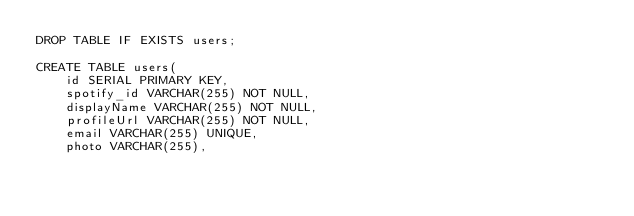<code> <loc_0><loc_0><loc_500><loc_500><_SQL_>DROP TABLE IF EXISTS users;

CREATE TABLE users(
    id SERIAL PRIMARY KEY,
    spotify_id VARCHAR(255) NOT NULL,
    displayName VARCHAR(255) NOT NULL,
    profileUrl VARCHAR(255) NOT NULL,
    email VARCHAR(255) UNIQUE,
    photo VARCHAR(255),</code> 